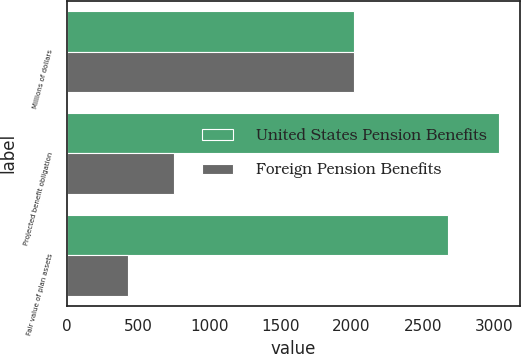Convert chart. <chart><loc_0><loc_0><loc_500><loc_500><stacked_bar_chart><ecel><fcel>Millions of dollars<fcel>Projected benefit obligation<fcel>Fair value of plan assets<nl><fcel>United States Pension Benefits<fcel>2018<fcel>3033<fcel>2676<nl><fcel>Foreign Pension Benefits<fcel>2018<fcel>753<fcel>430<nl></chart> 